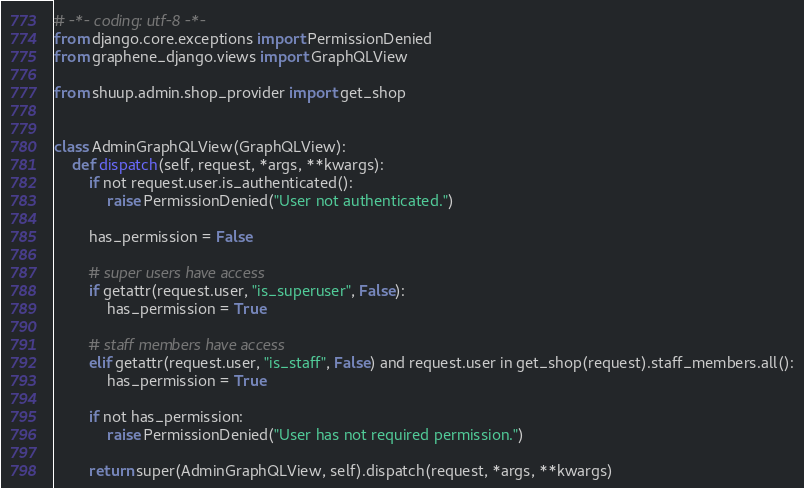<code> <loc_0><loc_0><loc_500><loc_500><_Python_># -*- coding: utf-8 -*-
from django.core.exceptions import PermissionDenied
from graphene_django.views import GraphQLView

from shuup.admin.shop_provider import get_shop


class AdminGraphQLView(GraphQLView):
    def dispatch(self, request, *args, **kwargs):
        if not request.user.is_authenticated():
            raise PermissionDenied("User not authenticated.")

        has_permission = False

        # super users have access
        if getattr(request.user, "is_superuser", False):
            has_permission = True

        # staff members have access
        elif getattr(request.user, "is_staff", False) and request.user in get_shop(request).staff_members.all():
            has_permission = True

        if not has_permission:
            raise PermissionDenied("User has not required permission.")

        return super(AdminGraphQLView, self).dispatch(request, *args, **kwargs)
</code> 